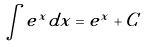<formula> <loc_0><loc_0><loc_500><loc_500>\int e ^ { x } d x = e ^ { x } + C</formula> 